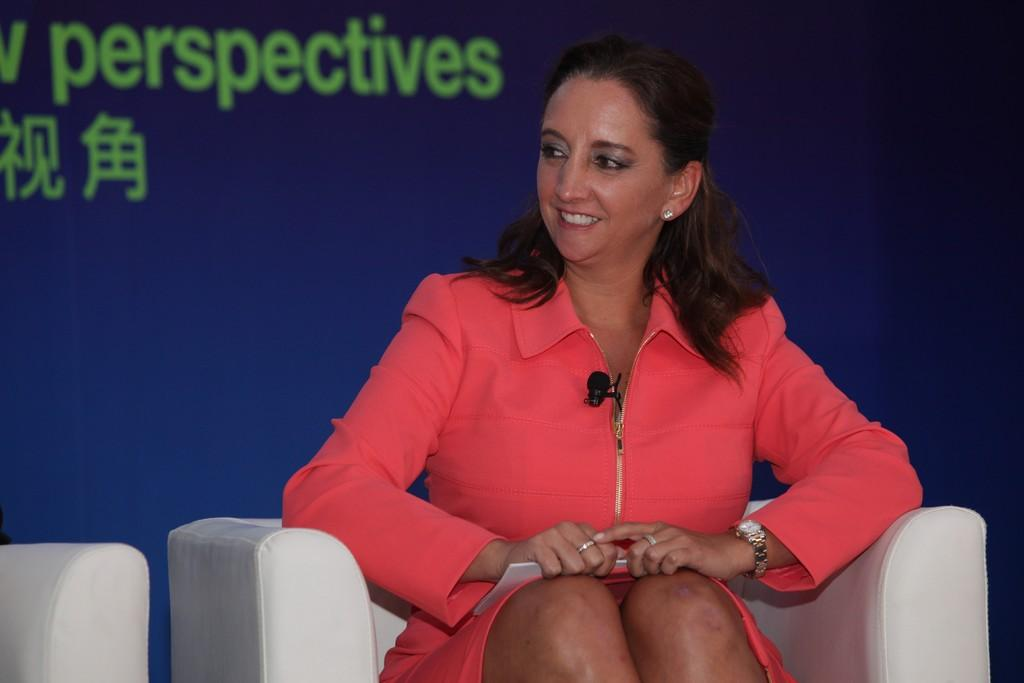Who is the main subject in the image? There is a lady in the center of the image. What can be seen in the background of the image? There is a projector screen in the background of the image. How many geese are present in the image? There are no geese present in the image. What type of reward is the lady holding in the image? The image does not show the lady holding any reward. 